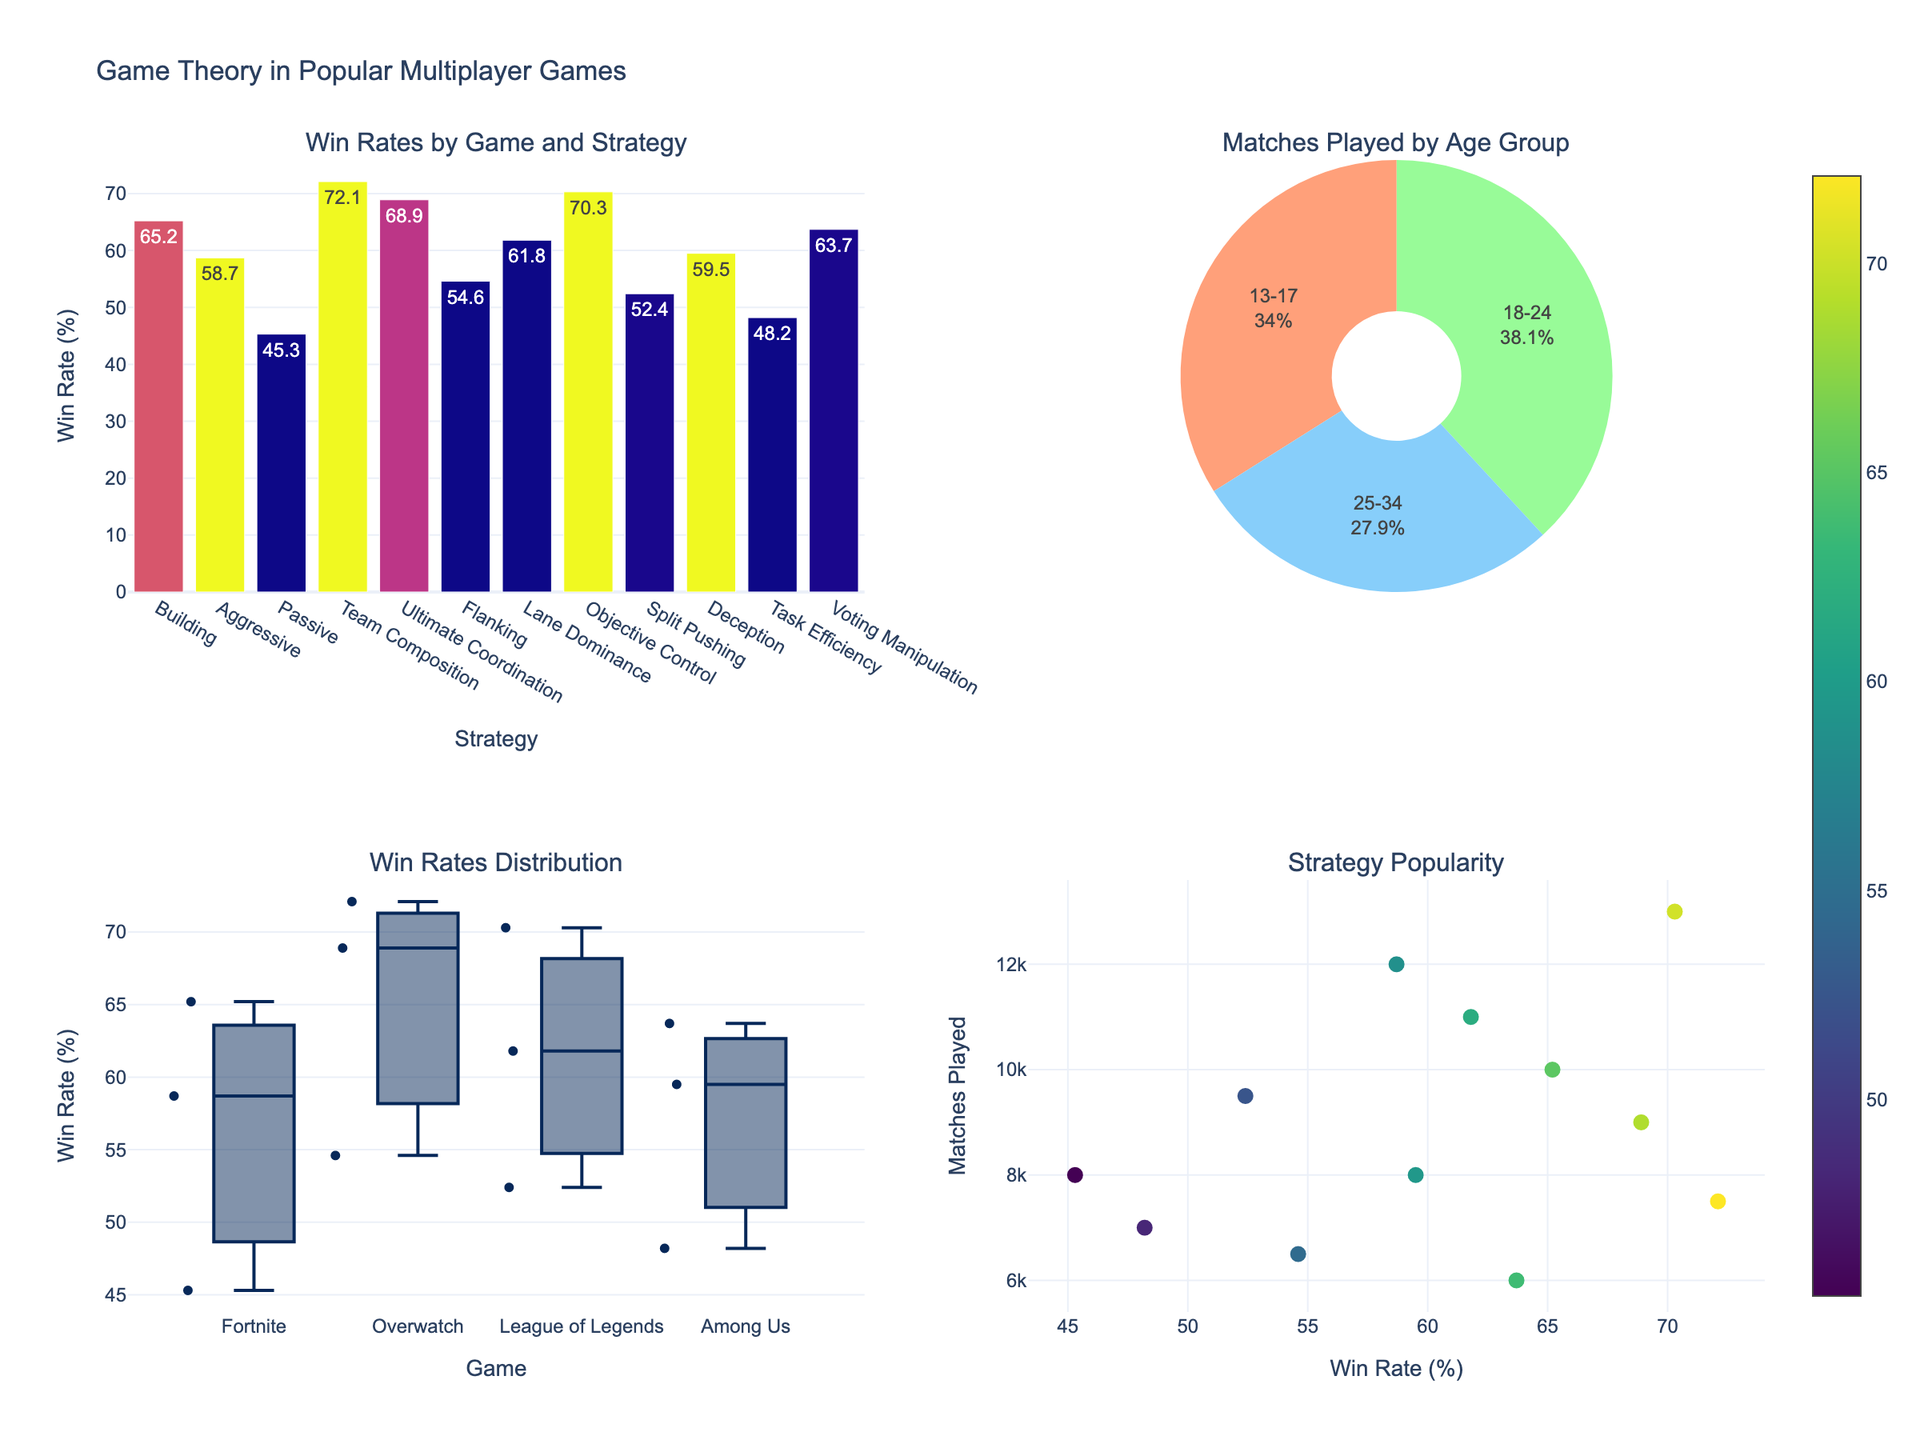What is the minimum win rate among the strategies shown in the bar chart? To find the minimum win rate, we need to inspect the bar chart in the "Win Rates by Game and Strategy" subplot to identify the lowest bar.
Answer: Passive strategy in Fortnite, 45.3% Which game has the highest win rate and what is the strategy associated with it? Look at the bar chart in the "Win Rates by Game and Strategy" subplot. Identify the tallest bar and note down the game and strategy.
Answer: Overwatch, Team Composition, 72.1% How does the win rate of the "Aggressive" strategy in Fortnite compare to the "Flanking" strategy in Overwatch? Check the bar heights for both strategies in their respective games from the "Win Rates by Game and Strategy" subplot. Compare their heights and associated values.
Answer: Aggressive is higher, 58.7% vs 54.6% What age group played the most matches and what percentage of the total does this represent? Refer to the pie chart in the "Matches Played by Age Group" subplot. Identify the largest slice and its corresponding label, then read the percentage displayed on the chart.
Answer: 18-24 age group, approximately 40% Which strategy shows the widest range of win rates in the box plot? Examine the "Win Rates Distribution" box plot. The strategy with the widest range will have the largest vertical span between the whiskers or the outliers.
Answer: Overwatch What is the total number of matches played by players aged 25-34? The pie chart in the "Matches Played by Age Group" subplot shows the proportion of matches for each age group. Find the slice for 25-34 and estimate the total matches played.
Answer: Approximately 40% of the total How does the win rate distribution in League of Legends compare to Fortnite? Compare the positions and spread of the box plots for League of Legends and Fortnite in the "Win Rates Distribution" subplot. Look at the median line, quartiles, and presence of outliers.
Answer: League of Legends shows higher median and less spread Which strategy has the highest win rate in Among Us and what might be a key factor in its success? Look at the "Win Rates by Game and Strategy" bar chart for Among Us strategies. Identify the strategy with the highest win rate and infer possible factors from its nature.
Answer: Voting Manipulation, 63.7%; key factor might be social influence/manipulation What is the correlation between win rate and matches played in general? Refer to the scatter plot "Strategy Popularity." Observe the trend between the points plotted with win rate on the x-axis and matches played on the y-axis.
Answer: Positive trend, higher win rate generally indicates higher matches played What is the range of win rates for different strategies in Fortnite observed in the box plot? Look at the "Win Rates Distribution" box plot for the data points associated with Fortnite. Note the highest and lowest points for win rates.
Answer: Approximately between 45.3% and 65.2% 